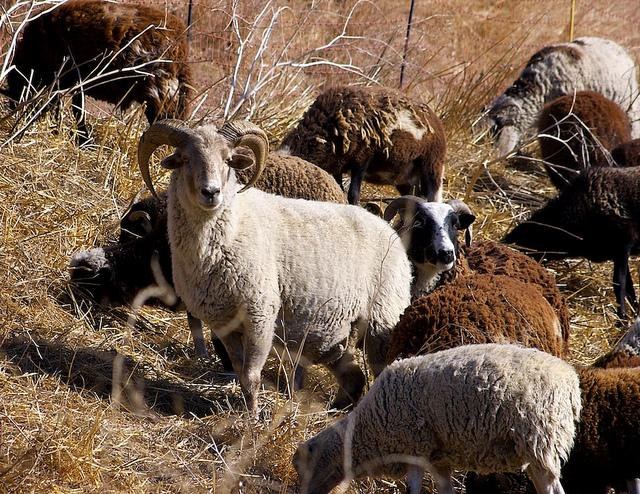Why are the sheep difference colors? different breeds 